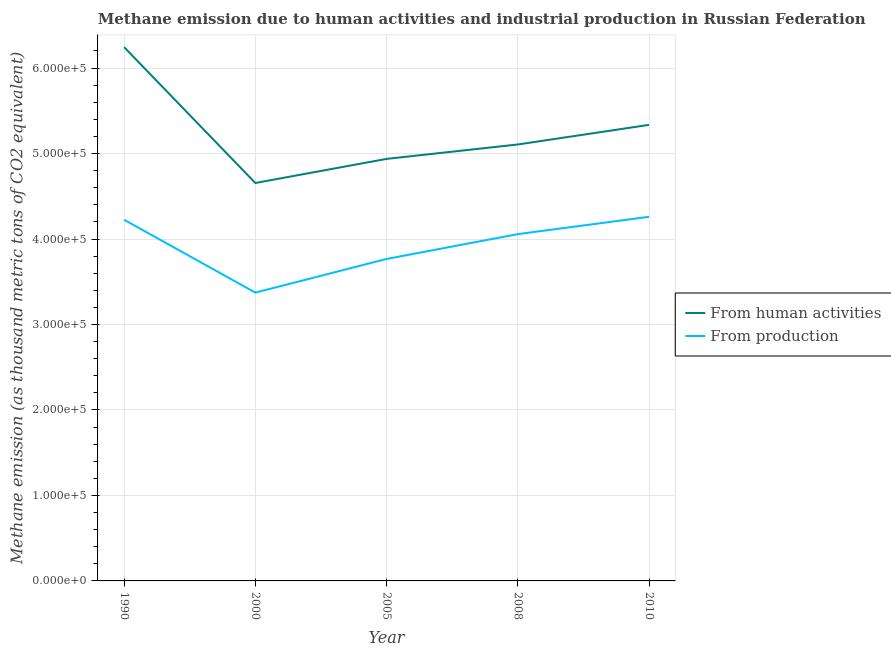How many different coloured lines are there?
Give a very brief answer. 2. Is the number of lines equal to the number of legend labels?
Your answer should be compact. Yes. What is the amount of emissions generated from industries in 2000?
Offer a very short reply. 3.37e+05. Across all years, what is the maximum amount of emissions generated from industries?
Your response must be concise. 4.26e+05. Across all years, what is the minimum amount of emissions from human activities?
Give a very brief answer. 4.66e+05. What is the total amount of emissions from human activities in the graph?
Your response must be concise. 2.63e+06. What is the difference between the amount of emissions generated from industries in 1990 and that in 2005?
Make the answer very short. 4.58e+04. What is the difference between the amount of emissions from human activities in 2000 and the amount of emissions generated from industries in 2008?
Keep it short and to the point. 5.98e+04. What is the average amount of emissions from human activities per year?
Your response must be concise. 5.26e+05. In the year 2005, what is the difference between the amount of emissions from human activities and amount of emissions generated from industries?
Give a very brief answer. 1.17e+05. What is the ratio of the amount of emissions from human activities in 1990 to that in 2010?
Your answer should be very brief. 1.17. Is the amount of emissions from human activities in 1990 less than that in 2008?
Provide a short and direct response. No. Is the difference between the amount of emissions from human activities in 2000 and 2010 greater than the difference between the amount of emissions generated from industries in 2000 and 2010?
Offer a terse response. Yes. What is the difference between the highest and the second highest amount of emissions generated from industries?
Offer a very short reply. 3466. What is the difference between the highest and the lowest amount of emissions from human activities?
Your answer should be very brief. 1.59e+05. In how many years, is the amount of emissions generated from industries greater than the average amount of emissions generated from industries taken over all years?
Give a very brief answer. 3. Is the sum of the amount of emissions generated from industries in 2000 and 2008 greater than the maximum amount of emissions from human activities across all years?
Your response must be concise. Yes. Does the amount of emissions from human activities monotonically increase over the years?
Offer a terse response. No. Is the amount of emissions from human activities strictly greater than the amount of emissions generated from industries over the years?
Your answer should be very brief. Yes. How many lines are there?
Provide a succinct answer. 2. How many years are there in the graph?
Give a very brief answer. 5. What is the difference between two consecutive major ticks on the Y-axis?
Give a very brief answer. 1.00e+05. Are the values on the major ticks of Y-axis written in scientific E-notation?
Provide a short and direct response. Yes. Does the graph contain grids?
Your response must be concise. Yes. Where does the legend appear in the graph?
Offer a terse response. Center right. How many legend labels are there?
Ensure brevity in your answer.  2. What is the title of the graph?
Provide a succinct answer. Methane emission due to human activities and industrial production in Russian Federation. Does "Research and Development" appear as one of the legend labels in the graph?
Your response must be concise. No. What is the label or title of the Y-axis?
Your response must be concise. Methane emission (as thousand metric tons of CO2 equivalent). What is the Methane emission (as thousand metric tons of CO2 equivalent) of From human activities in 1990?
Your answer should be very brief. 6.24e+05. What is the Methane emission (as thousand metric tons of CO2 equivalent) of From production in 1990?
Ensure brevity in your answer.  4.23e+05. What is the Methane emission (as thousand metric tons of CO2 equivalent) in From human activities in 2000?
Ensure brevity in your answer.  4.66e+05. What is the Methane emission (as thousand metric tons of CO2 equivalent) of From production in 2000?
Your answer should be very brief. 3.37e+05. What is the Methane emission (as thousand metric tons of CO2 equivalent) of From human activities in 2005?
Ensure brevity in your answer.  4.94e+05. What is the Methane emission (as thousand metric tons of CO2 equivalent) of From production in 2005?
Provide a succinct answer. 3.77e+05. What is the Methane emission (as thousand metric tons of CO2 equivalent) of From human activities in 2008?
Ensure brevity in your answer.  5.11e+05. What is the Methane emission (as thousand metric tons of CO2 equivalent) in From production in 2008?
Your answer should be very brief. 4.06e+05. What is the Methane emission (as thousand metric tons of CO2 equivalent) in From human activities in 2010?
Provide a short and direct response. 5.34e+05. What is the Methane emission (as thousand metric tons of CO2 equivalent) in From production in 2010?
Ensure brevity in your answer.  4.26e+05. Across all years, what is the maximum Methane emission (as thousand metric tons of CO2 equivalent) in From human activities?
Keep it short and to the point. 6.24e+05. Across all years, what is the maximum Methane emission (as thousand metric tons of CO2 equivalent) of From production?
Your response must be concise. 4.26e+05. Across all years, what is the minimum Methane emission (as thousand metric tons of CO2 equivalent) in From human activities?
Make the answer very short. 4.66e+05. Across all years, what is the minimum Methane emission (as thousand metric tons of CO2 equivalent) of From production?
Make the answer very short. 3.37e+05. What is the total Methane emission (as thousand metric tons of CO2 equivalent) of From human activities in the graph?
Provide a short and direct response. 2.63e+06. What is the total Methane emission (as thousand metric tons of CO2 equivalent) in From production in the graph?
Offer a very short reply. 1.97e+06. What is the difference between the Methane emission (as thousand metric tons of CO2 equivalent) of From human activities in 1990 and that in 2000?
Give a very brief answer. 1.59e+05. What is the difference between the Methane emission (as thousand metric tons of CO2 equivalent) in From production in 1990 and that in 2000?
Provide a succinct answer. 8.52e+04. What is the difference between the Methane emission (as thousand metric tons of CO2 equivalent) in From human activities in 1990 and that in 2005?
Provide a short and direct response. 1.31e+05. What is the difference between the Methane emission (as thousand metric tons of CO2 equivalent) in From production in 1990 and that in 2005?
Make the answer very short. 4.58e+04. What is the difference between the Methane emission (as thousand metric tons of CO2 equivalent) of From human activities in 1990 and that in 2008?
Offer a terse response. 1.14e+05. What is the difference between the Methane emission (as thousand metric tons of CO2 equivalent) in From production in 1990 and that in 2008?
Provide a succinct answer. 1.68e+04. What is the difference between the Methane emission (as thousand metric tons of CO2 equivalent) of From human activities in 1990 and that in 2010?
Offer a very short reply. 9.09e+04. What is the difference between the Methane emission (as thousand metric tons of CO2 equivalent) in From production in 1990 and that in 2010?
Offer a terse response. -3466. What is the difference between the Methane emission (as thousand metric tons of CO2 equivalent) in From human activities in 2000 and that in 2005?
Make the answer very short. -2.82e+04. What is the difference between the Methane emission (as thousand metric tons of CO2 equivalent) in From production in 2000 and that in 2005?
Offer a very short reply. -3.94e+04. What is the difference between the Methane emission (as thousand metric tons of CO2 equivalent) in From human activities in 2000 and that in 2008?
Keep it short and to the point. -4.51e+04. What is the difference between the Methane emission (as thousand metric tons of CO2 equivalent) in From production in 2000 and that in 2008?
Your response must be concise. -6.84e+04. What is the difference between the Methane emission (as thousand metric tons of CO2 equivalent) of From human activities in 2000 and that in 2010?
Your response must be concise. -6.80e+04. What is the difference between the Methane emission (as thousand metric tons of CO2 equivalent) in From production in 2000 and that in 2010?
Offer a terse response. -8.87e+04. What is the difference between the Methane emission (as thousand metric tons of CO2 equivalent) of From human activities in 2005 and that in 2008?
Give a very brief answer. -1.69e+04. What is the difference between the Methane emission (as thousand metric tons of CO2 equivalent) in From production in 2005 and that in 2008?
Your response must be concise. -2.90e+04. What is the difference between the Methane emission (as thousand metric tons of CO2 equivalent) of From human activities in 2005 and that in 2010?
Offer a terse response. -3.98e+04. What is the difference between the Methane emission (as thousand metric tons of CO2 equivalent) in From production in 2005 and that in 2010?
Keep it short and to the point. -4.93e+04. What is the difference between the Methane emission (as thousand metric tons of CO2 equivalent) of From human activities in 2008 and that in 2010?
Offer a very short reply. -2.29e+04. What is the difference between the Methane emission (as thousand metric tons of CO2 equivalent) of From production in 2008 and that in 2010?
Your answer should be compact. -2.03e+04. What is the difference between the Methane emission (as thousand metric tons of CO2 equivalent) of From human activities in 1990 and the Methane emission (as thousand metric tons of CO2 equivalent) of From production in 2000?
Provide a succinct answer. 2.87e+05. What is the difference between the Methane emission (as thousand metric tons of CO2 equivalent) of From human activities in 1990 and the Methane emission (as thousand metric tons of CO2 equivalent) of From production in 2005?
Your response must be concise. 2.48e+05. What is the difference between the Methane emission (as thousand metric tons of CO2 equivalent) in From human activities in 1990 and the Methane emission (as thousand metric tons of CO2 equivalent) in From production in 2008?
Provide a short and direct response. 2.19e+05. What is the difference between the Methane emission (as thousand metric tons of CO2 equivalent) of From human activities in 1990 and the Methane emission (as thousand metric tons of CO2 equivalent) of From production in 2010?
Offer a very short reply. 1.98e+05. What is the difference between the Methane emission (as thousand metric tons of CO2 equivalent) of From human activities in 2000 and the Methane emission (as thousand metric tons of CO2 equivalent) of From production in 2005?
Your answer should be very brief. 8.89e+04. What is the difference between the Methane emission (as thousand metric tons of CO2 equivalent) in From human activities in 2000 and the Methane emission (as thousand metric tons of CO2 equivalent) in From production in 2008?
Provide a succinct answer. 5.98e+04. What is the difference between the Methane emission (as thousand metric tons of CO2 equivalent) of From human activities in 2000 and the Methane emission (as thousand metric tons of CO2 equivalent) of From production in 2010?
Ensure brevity in your answer.  3.95e+04. What is the difference between the Methane emission (as thousand metric tons of CO2 equivalent) of From human activities in 2005 and the Methane emission (as thousand metric tons of CO2 equivalent) of From production in 2008?
Ensure brevity in your answer.  8.80e+04. What is the difference between the Methane emission (as thousand metric tons of CO2 equivalent) in From human activities in 2005 and the Methane emission (as thousand metric tons of CO2 equivalent) in From production in 2010?
Your response must be concise. 6.78e+04. What is the difference between the Methane emission (as thousand metric tons of CO2 equivalent) of From human activities in 2008 and the Methane emission (as thousand metric tons of CO2 equivalent) of From production in 2010?
Provide a short and direct response. 8.46e+04. What is the average Methane emission (as thousand metric tons of CO2 equivalent) of From human activities per year?
Your answer should be very brief. 5.26e+05. What is the average Methane emission (as thousand metric tons of CO2 equivalent) in From production per year?
Provide a succinct answer. 3.94e+05. In the year 1990, what is the difference between the Methane emission (as thousand metric tons of CO2 equivalent) in From human activities and Methane emission (as thousand metric tons of CO2 equivalent) in From production?
Your answer should be very brief. 2.02e+05. In the year 2000, what is the difference between the Methane emission (as thousand metric tons of CO2 equivalent) of From human activities and Methane emission (as thousand metric tons of CO2 equivalent) of From production?
Keep it short and to the point. 1.28e+05. In the year 2005, what is the difference between the Methane emission (as thousand metric tons of CO2 equivalent) in From human activities and Methane emission (as thousand metric tons of CO2 equivalent) in From production?
Offer a very short reply. 1.17e+05. In the year 2008, what is the difference between the Methane emission (as thousand metric tons of CO2 equivalent) of From human activities and Methane emission (as thousand metric tons of CO2 equivalent) of From production?
Offer a terse response. 1.05e+05. In the year 2010, what is the difference between the Methane emission (as thousand metric tons of CO2 equivalent) in From human activities and Methane emission (as thousand metric tons of CO2 equivalent) in From production?
Give a very brief answer. 1.08e+05. What is the ratio of the Methane emission (as thousand metric tons of CO2 equivalent) in From human activities in 1990 to that in 2000?
Your response must be concise. 1.34. What is the ratio of the Methane emission (as thousand metric tons of CO2 equivalent) of From production in 1990 to that in 2000?
Make the answer very short. 1.25. What is the ratio of the Methane emission (as thousand metric tons of CO2 equivalent) of From human activities in 1990 to that in 2005?
Make the answer very short. 1.26. What is the ratio of the Methane emission (as thousand metric tons of CO2 equivalent) of From production in 1990 to that in 2005?
Offer a very short reply. 1.12. What is the ratio of the Methane emission (as thousand metric tons of CO2 equivalent) of From human activities in 1990 to that in 2008?
Your response must be concise. 1.22. What is the ratio of the Methane emission (as thousand metric tons of CO2 equivalent) in From production in 1990 to that in 2008?
Your response must be concise. 1.04. What is the ratio of the Methane emission (as thousand metric tons of CO2 equivalent) of From human activities in 1990 to that in 2010?
Make the answer very short. 1.17. What is the ratio of the Methane emission (as thousand metric tons of CO2 equivalent) of From human activities in 2000 to that in 2005?
Keep it short and to the point. 0.94. What is the ratio of the Methane emission (as thousand metric tons of CO2 equivalent) in From production in 2000 to that in 2005?
Provide a short and direct response. 0.9. What is the ratio of the Methane emission (as thousand metric tons of CO2 equivalent) in From human activities in 2000 to that in 2008?
Make the answer very short. 0.91. What is the ratio of the Methane emission (as thousand metric tons of CO2 equivalent) of From production in 2000 to that in 2008?
Provide a short and direct response. 0.83. What is the ratio of the Methane emission (as thousand metric tons of CO2 equivalent) of From human activities in 2000 to that in 2010?
Give a very brief answer. 0.87. What is the ratio of the Methane emission (as thousand metric tons of CO2 equivalent) in From production in 2000 to that in 2010?
Offer a very short reply. 0.79. What is the ratio of the Methane emission (as thousand metric tons of CO2 equivalent) of From production in 2005 to that in 2008?
Offer a very short reply. 0.93. What is the ratio of the Methane emission (as thousand metric tons of CO2 equivalent) in From human activities in 2005 to that in 2010?
Your answer should be very brief. 0.93. What is the ratio of the Methane emission (as thousand metric tons of CO2 equivalent) in From production in 2005 to that in 2010?
Your response must be concise. 0.88. What is the ratio of the Methane emission (as thousand metric tons of CO2 equivalent) of From human activities in 2008 to that in 2010?
Ensure brevity in your answer.  0.96. What is the ratio of the Methane emission (as thousand metric tons of CO2 equivalent) in From production in 2008 to that in 2010?
Offer a very short reply. 0.95. What is the difference between the highest and the second highest Methane emission (as thousand metric tons of CO2 equivalent) of From human activities?
Provide a succinct answer. 9.09e+04. What is the difference between the highest and the second highest Methane emission (as thousand metric tons of CO2 equivalent) in From production?
Keep it short and to the point. 3466. What is the difference between the highest and the lowest Methane emission (as thousand metric tons of CO2 equivalent) in From human activities?
Your response must be concise. 1.59e+05. What is the difference between the highest and the lowest Methane emission (as thousand metric tons of CO2 equivalent) of From production?
Your response must be concise. 8.87e+04. 